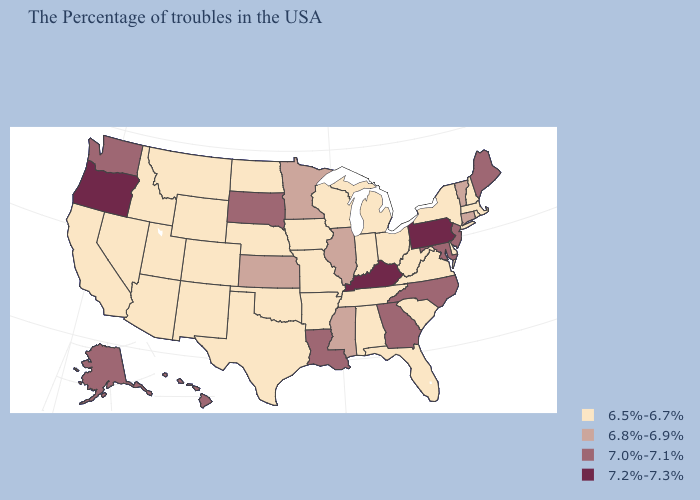Which states have the highest value in the USA?
Give a very brief answer. Pennsylvania, Kentucky, Oregon. What is the value of South Dakota?
Short answer required. 7.0%-7.1%. Which states have the lowest value in the USA?
Answer briefly. Massachusetts, Rhode Island, New Hampshire, New York, Delaware, Virginia, South Carolina, West Virginia, Ohio, Florida, Michigan, Indiana, Alabama, Tennessee, Wisconsin, Missouri, Arkansas, Iowa, Nebraska, Oklahoma, Texas, North Dakota, Wyoming, Colorado, New Mexico, Utah, Montana, Arizona, Idaho, Nevada, California. Does the map have missing data?
Quick response, please. No. What is the lowest value in the MidWest?
Short answer required. 6.5%-6.7%. Name the states that have a value in the range 7.0%-7.1%?
Short answer required. Maine, New Jersey, Maryland, North Carolina, Georgia, Louisiana, South Dakota, Washington, Alaska, Hawaii. What is the value of Ohio?
Answer briefly. 6.5%-6.7%. Among the states that border Nevada , which have the lowest value?
Keep it brief. Utah, Arizona, Idaho, California. Name the states that have a value in the range 6.8%-6.9%?
Keep it brief. Vermont, Connecticut, Illinois, Mississippi, Minnesota, Kansas. What is the value of Massachusetts?
Short answer required. 6.5%-6.7%. What is the value of Delaware?
Keep it brief. 6.5%-6.7%. Does Washington have the lowest value in the USA?
Answer briefly. No. What is the lowest value in the USA?
Give a very brief answer. 6.5%-6.7%. Name the states that have a value in the range 6.5%-6.7%?
Be succinct. Massachusetts, Rhode Island, New Hampshire, New York, Delaware, Virginia, South Carolina, West Virginia, Ohio, Florida, Michigan, Indiana, Alabama, Tennessee, Wisconsin, Missouri, Arkansas, Iowa, Nebraska, Oklahoma, Texas, North Dakota, Wyoming, Colorado, New Mexico, Utah, Montana, Arizona, Idaho, Nevada, California. 